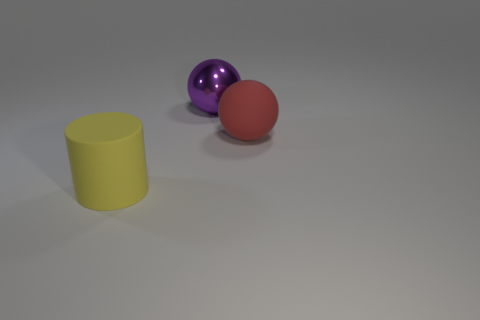Add 3 metallic objects. How many objects exist? 6 Subtract all cylinders. How many objects are left? 2 Subtract all purple things. Subtract all yellow cylinders. How many objects are left? 1 Add 3 large rubber things. How many large rubber things are left? 5 Add 3 big purple spheres. How many big purple spheres exist? 4 Subtract 0 gray blocks. How many objects are left? 3 